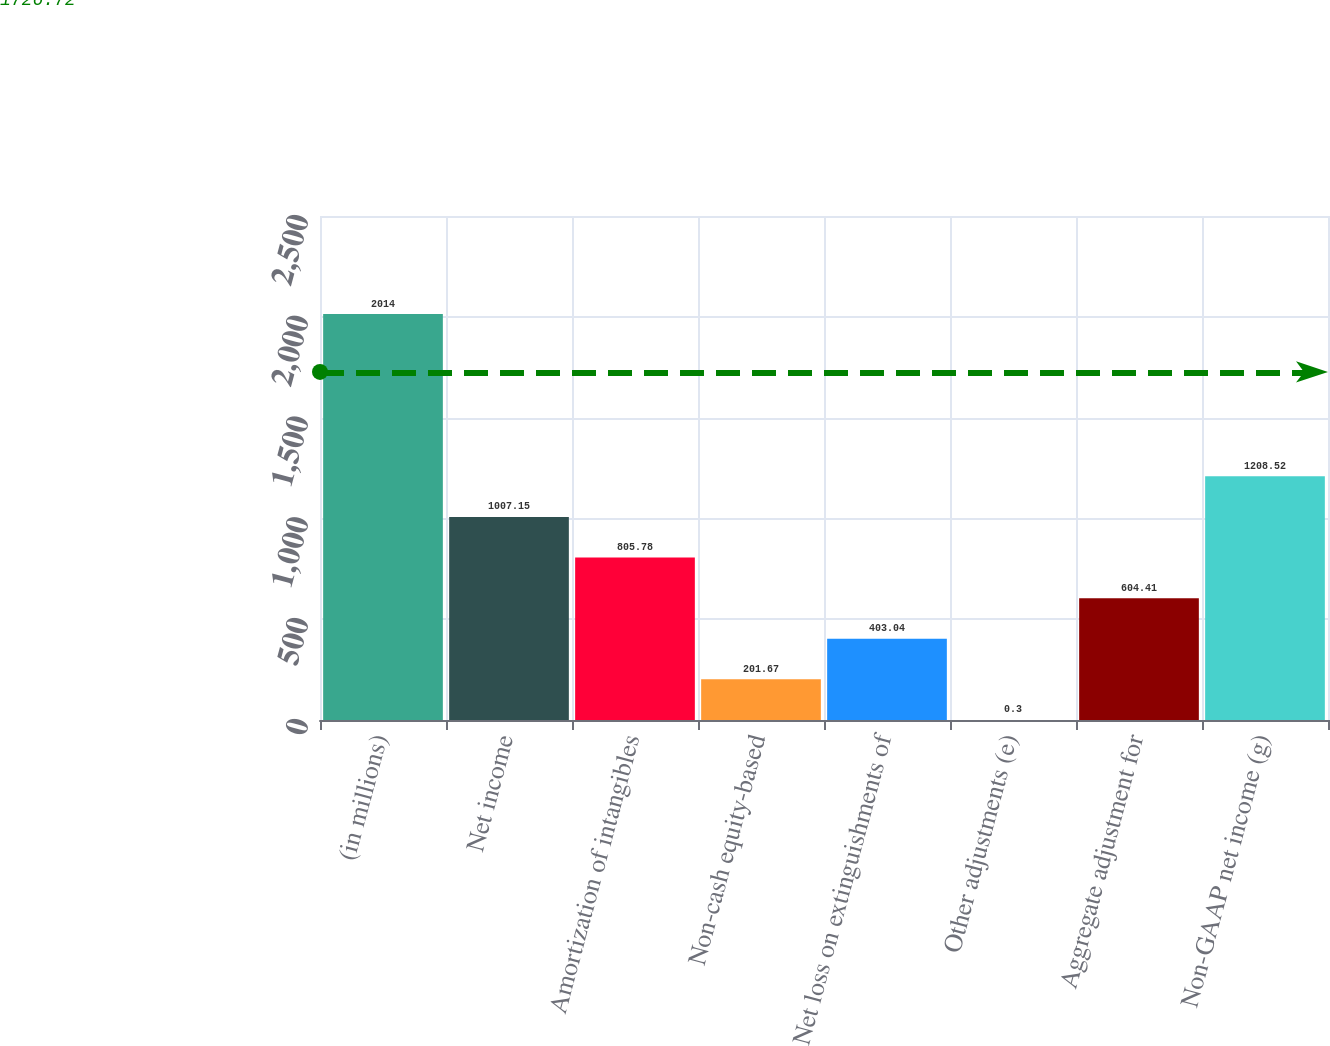Convert chart. <chart><loc_0><loc_0><loc_500><loc_500><bar_chart><fcel>(in millions)<fcel>Net income<fcel>Amortization of intangibles<fcel>Non-cash equity-based<fcel>Net loss on extinguishments of<fcel>Other adjustments (e)<fcel>Aggregate adjustment for<fcel>Non-GAAP net income (g)<nl><fcel>2014<fcel>1007.15<fcel>805.78<fcel>201.67<fcel>403.04<fcel>0.3<fcel>604.41<fcel>1208.52<nl></chart> 